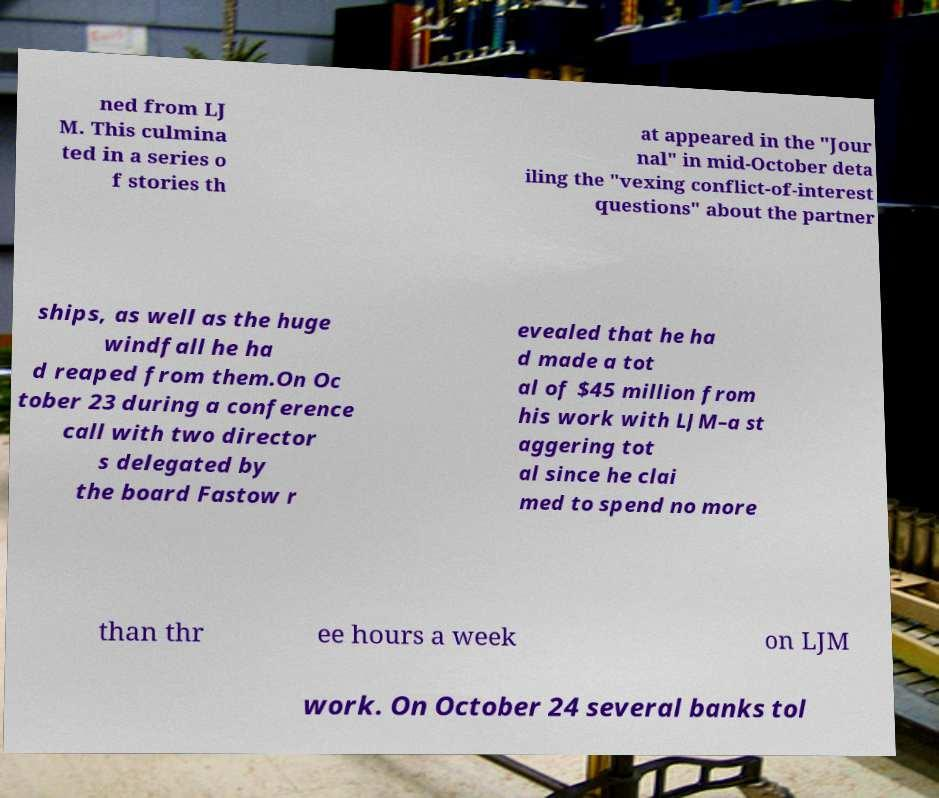Could you extract and type out the text from this image? ned from LJ M. This culmina ted in a series o f stories th at appeared in the "Jour nal" in mid-October deta iling the "vexing conflict-of-interest questions" about the partner ships, as well as the huge windfall he ha d reaped from them.On Oc tober 23 during a conference call with two director s delegated by the board Fastow r evealed that he ha d made a tot al of $45 million from his work with LJM–a st aggering tot al since he clai med to spend no more than thr ee hours a week on LJM work. On October 24 several banks tol 